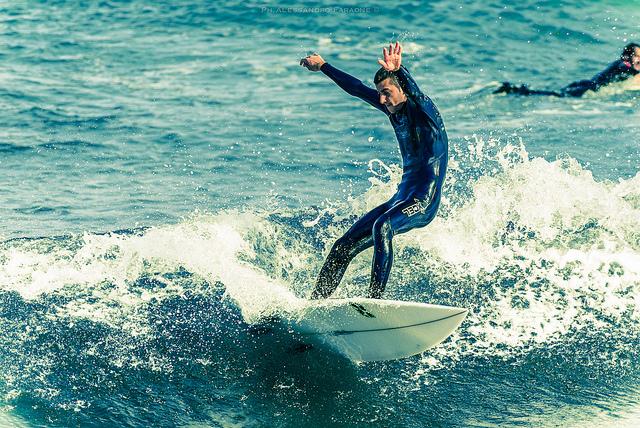How many fingers are spread on the surfer's hand?
Give a very brief answer. 5. What color is the person's suit?
Give a very brief answer. Blue. What is the man wearing?
Concise answer only. Wetsuit. What color wave is the man riding his board on?
Write a very short answer. Blue. 